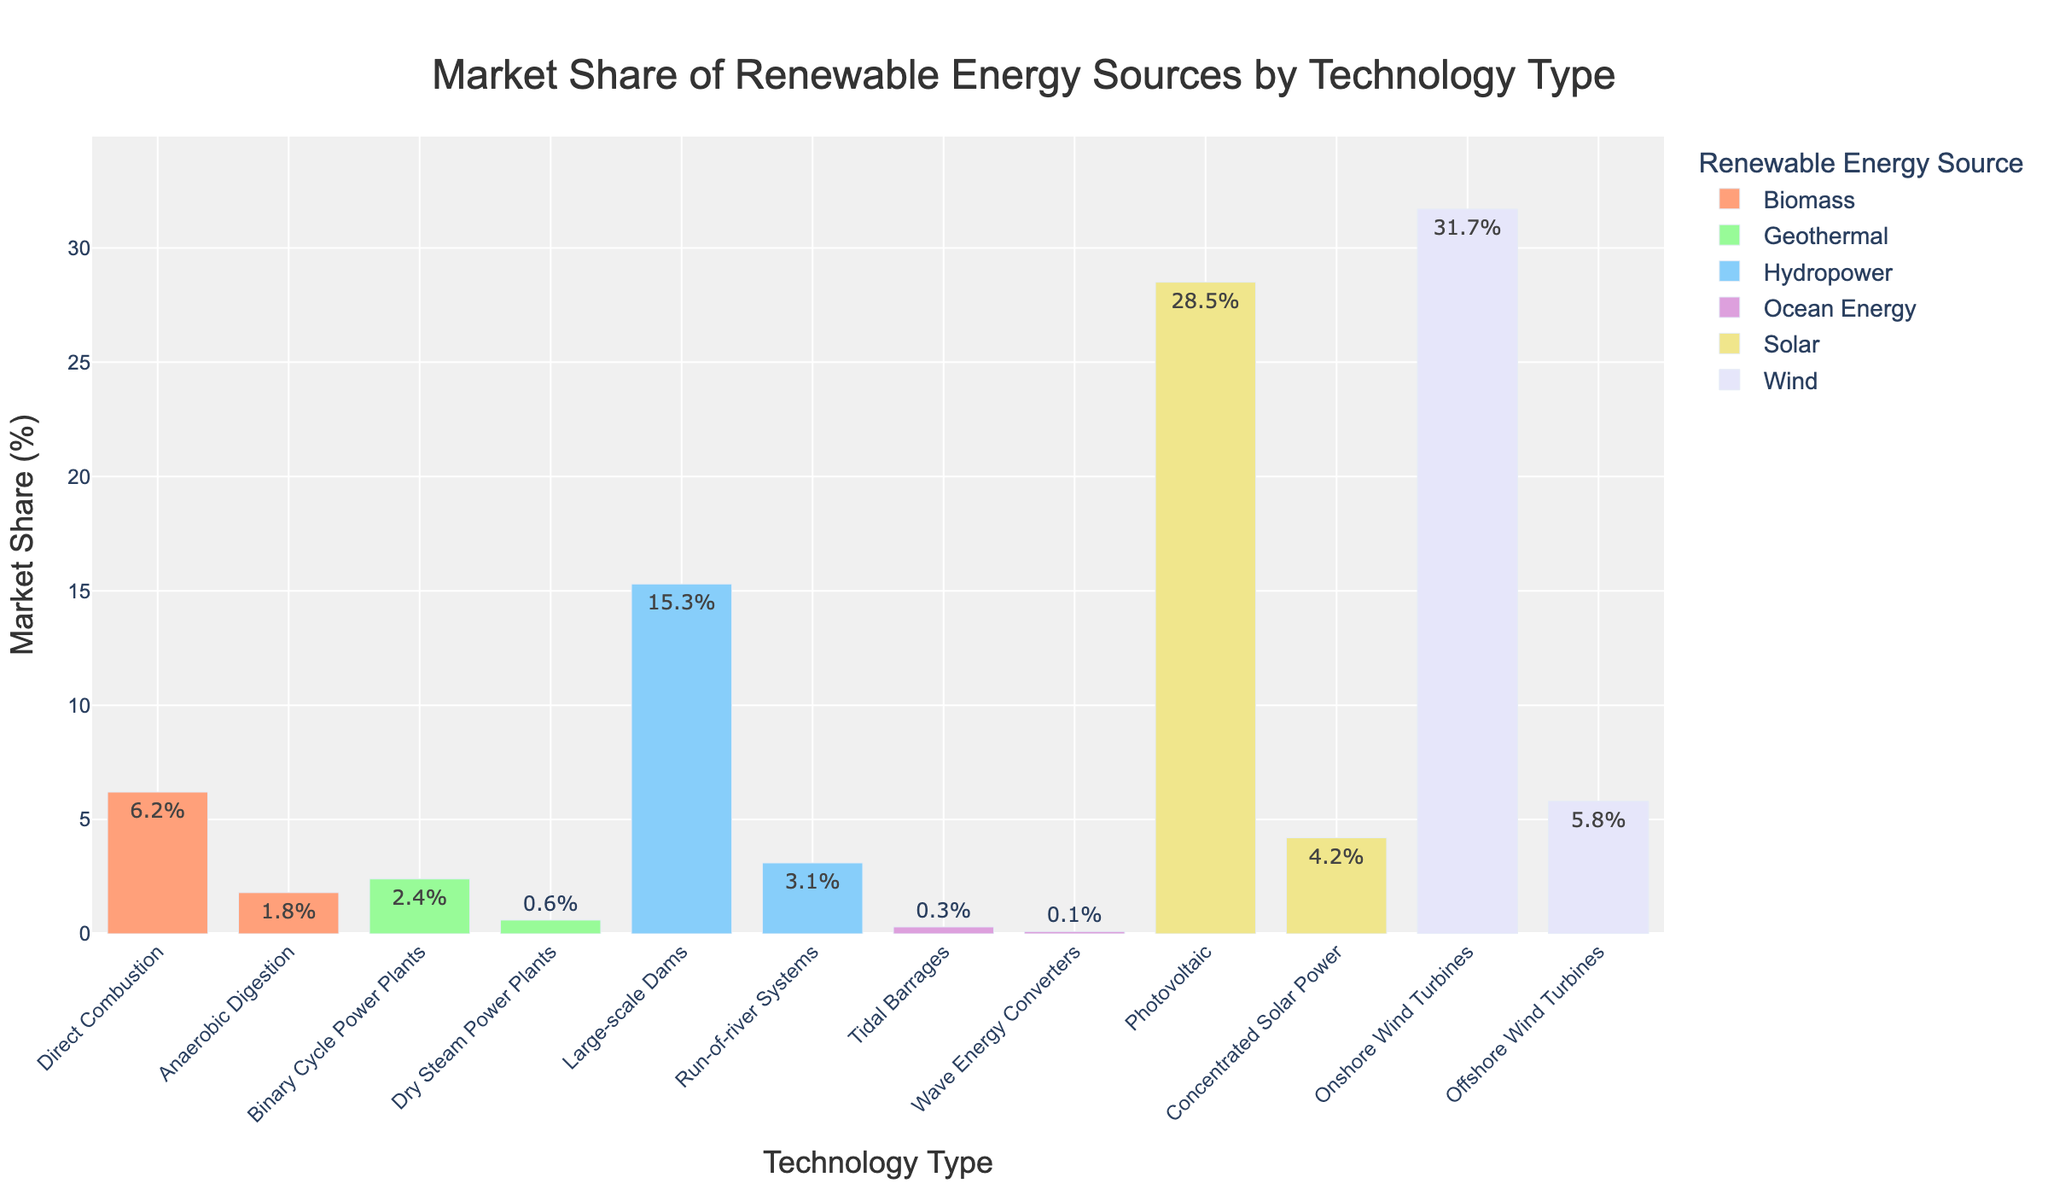What is the total market share of Wind energy, combining both onshore and offshore wind turbines? To find the total market share of Wind energy, add the market share of Onshore Wind Turbines (31.7%) and Offshore Wind Turbines (5.8%). The calculation is 31.7% + 5.8% = 37.5%.
Answer: 37.5% Which renewable energy source has the largest single market share, and what is that share? To determine the largest single market share, look for the highest value in the Market Share (%) column. Onshore Wind Turbines under Wind energy has the largest share with 31.7%.
Answer: Onshore Wind Turbines, 31.7% Which technology type has the smallest market share, and for which renewable energy source? To find the smallest market share, look for the lowest value in the Market Share (%) column. Wave Energy Converters under Ocean Energy has the smallest share with 0.1%.
Answer: Wave Energy Converters, Ocean Energy Compare the combined market share of all Biomass technologies to that of all Solar technologies. Which is greater and by how much? First, add the market shares of Biomass technologies: Direct Combustion (6.2%) and Anaerobic Digestion (1.8%), which totals to 8.0%. Then, add the market shares of Solar technologies: Photovoltaic (28.5%) and Concentrated Solar Power (4.2%), which totals to 32.7%. The difference is 32.7% - 8.0% = 24.7%.
Answer: Solar by 24.7% What is the average market share of all Hydropower technologies? For Hydropower, add the market share of Large-scale Dams (15.3%) and Run-of-river Systems (3.1%), which totals to 18.4%. Then, divide by the number of Hydropower technologies (2). The calculation is 18.4% / 2 = 9.2%.
Answer: 9.2% How does the market share of Photovoltaic Solar compare to that of Onshore Wind Turbines? Compare the market shares by directly looking at them: Photovoltaic Solar has 28.5%, while Onshore Wind Turbines have 31.7%. Onshore Wind Turbines have a higher market share than Photovoltaic Solar by 31.7% - 28.5% = 3.2%.
Answer: Onshore Wind Turbines by 3.2% What is the combined market share of all renewable energy sources except Wind? Sum up the market shares of all sources except Wind: Solar (28.5% + 4.2%), Hydropower (15.3% + 3.1%), Biomass (6.2% + 1.8%), Geothermal (2.4% + 0.6%), Ocean Energy (0.3% + 0.1%). Calculation: 32.7% + 18.4% + 8.0% + 3.0% + 0.4% = 62.5%.
Answer: 62.5% What is the market share difference between Large-scale Dams and Run-of-river Systems within Hydropower technologies? Subtract the market share of Run-of-river Systems (3.1%) from that of Large-scale Dams (15.3%). The calculation is 15.3% - 3.1% = 12.2%.
Answer: 12.2% Identify the visual color used for Geothermal technologies in the bar chart. Based on the colors defined in the code, the fifth color used, which is associated with Geothermal technologies, would be yellow. This color is visually assigned to Geothermal technologies in the bar chart.
Answer: Yellow What is the median market share of all technology types across all renewable energy sources? List the market shares in ascending order: 0.1%, 0.3%, 0.6%, 1.8%, 2.4%, 3.1%, 4.2%, 6.2%, 15.3%, 28.5%, 31.7%. Since there are 11 values, the median is the 6th value, which is 3.1%.
Answer: 3.1% 